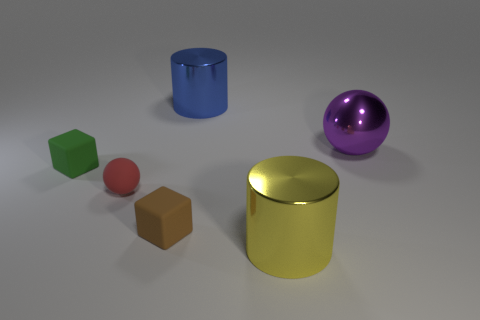Add 1 big blue matte cylinders. How many objects exist? 7 Subtract all cylinders. How many objects are left? 4 Add 5 red balls. How many red balls are left? 6 Add 2 large blue cylinders. How many large blue cylinders exist? 3 Subtract 0 green cylinders. How many objects are left? 6 Subtract all yellow cylinders. Subtract all tiny matte spheres. How many objects are left? 4 